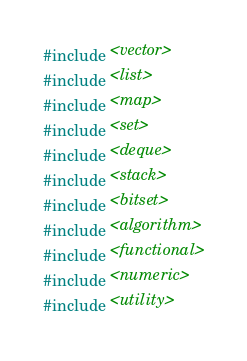<code> <loc_0><loc_0><loc_500><loc_500><_C++_>#include <vector>
#include <list>
#include <map>
#include <set>
#include <deque>
#include <stack>
#include <bitset>
#include <algorithm>
#include <functional>
#include <numeric>
#include <utility></code> 